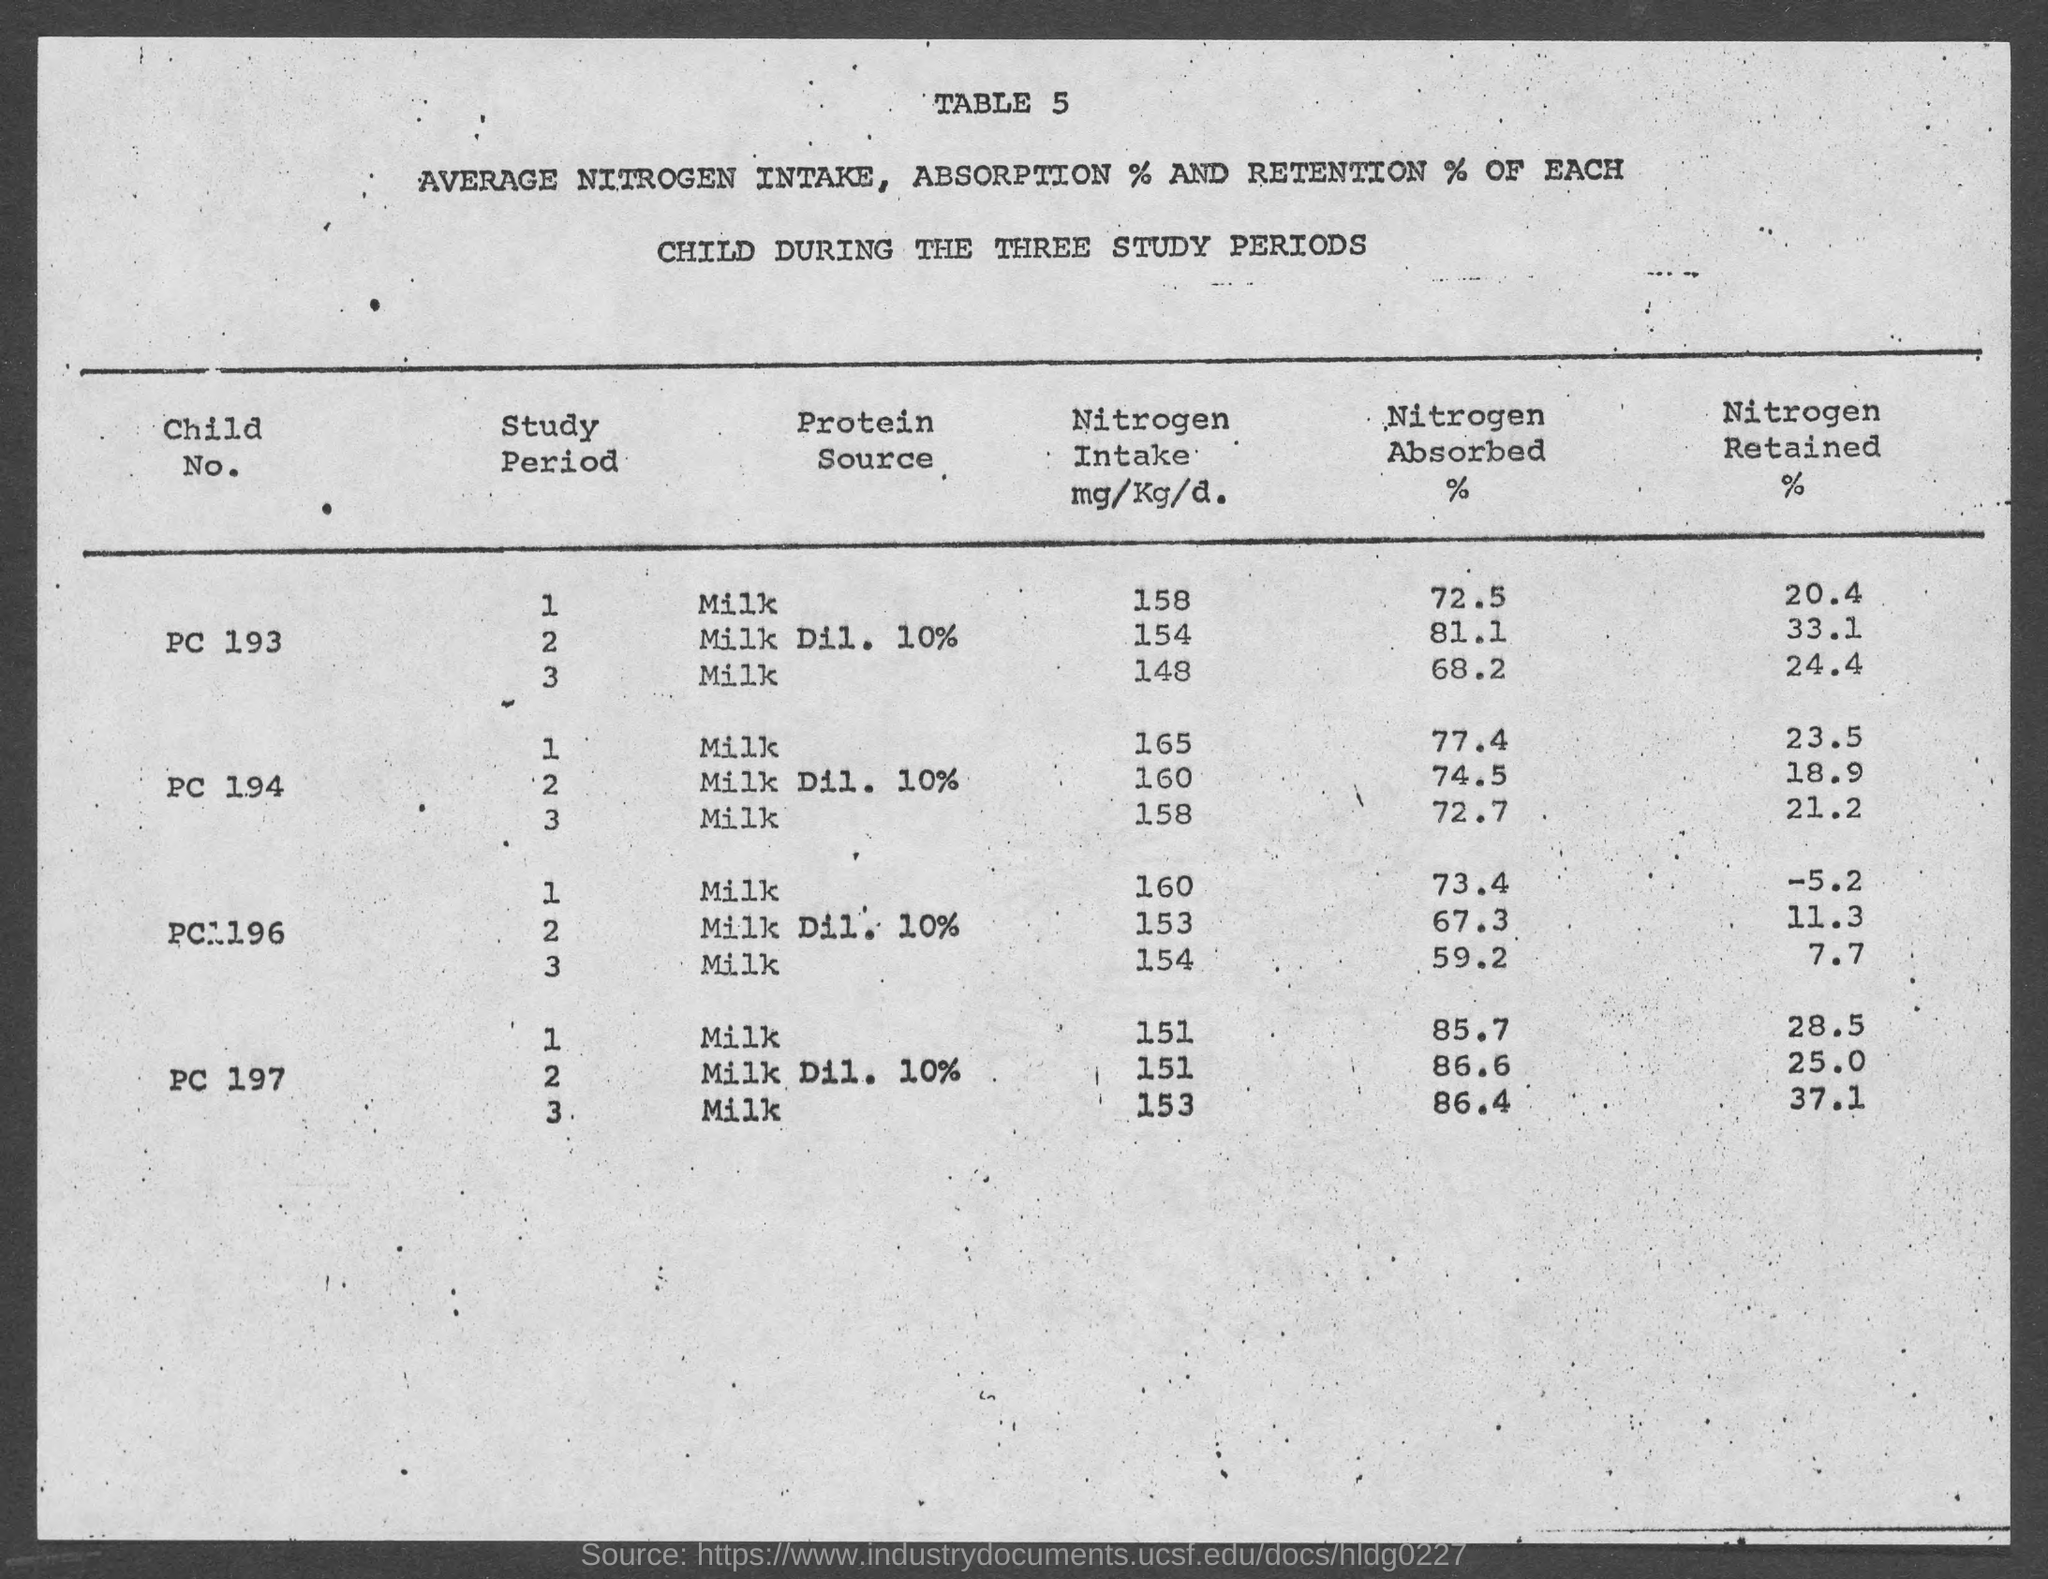What is the table number?
Offer a very short reply. 5. What percentage of nitrogen is absorbed by child number PC 193 during study period 1?
Give a very brief answer. 72.5. What percentage of nitrogen is retained by child number PC 193 during study period 3?
Make the answer very short. 24.4. How much nitrogen is intake by child number 197 during study period 3?
Provide a succinct answer. 153. What percentage of nitrogen is absorbed by child number PC 196 during study period 3?
Give a very brief answer. 59.2. 